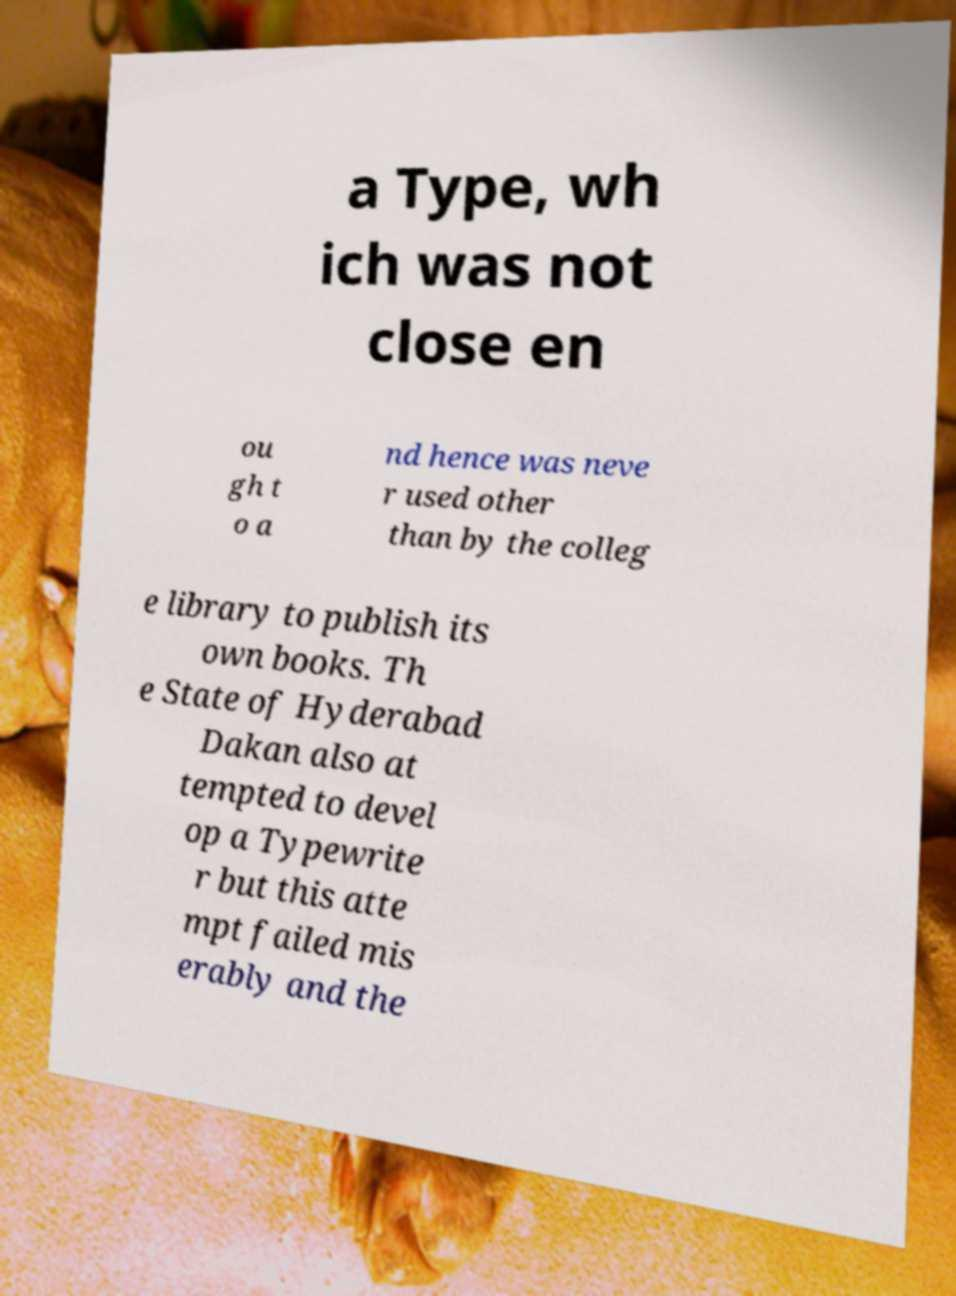Could you assist in decoding the text presented in this image and type it out clearly? a Type, wh ich was not close en ou gh t o a nd hence was neve r used other than by the colleg e library to publish its own books. Th e State of Hyderabad Dakan also at tempted to devel op a Typewrite r but this atte mpt failed mis erably and the 